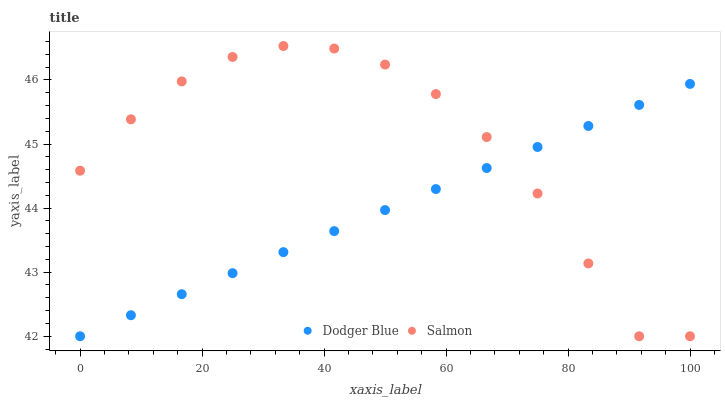Does Dodger Blue have the minimum area under the curve?
Answer yes or no. Yes. Does Salmon have the maximum area under the curve?
Answer yes or no. Yes. Does Dodger Blue have the maximum area under the curve?
Answer yes or no. No. Is Dodger Blue the smoothest?
Answer yes or no. Yes. Is Salmon the roughest?
Answer yes or no. Yes. Is Dodger Blue the roughest?
Answer yes or no. No. Does Salmon have the lowest value?
Answer yes or no. Yes. Does Salmon have the highest value?
Answer yes or no. Yes. Does Dodger Blue have the highest value?
Answer yes or no. No. Does Dodger Blue intersect Salmon?
Answer yes or no. Yes. Is Dodger Blue less than Salmon?
Answer yes or no. No. Is Dodger Blue greater than Salmon?
Answer yes or no. No. 